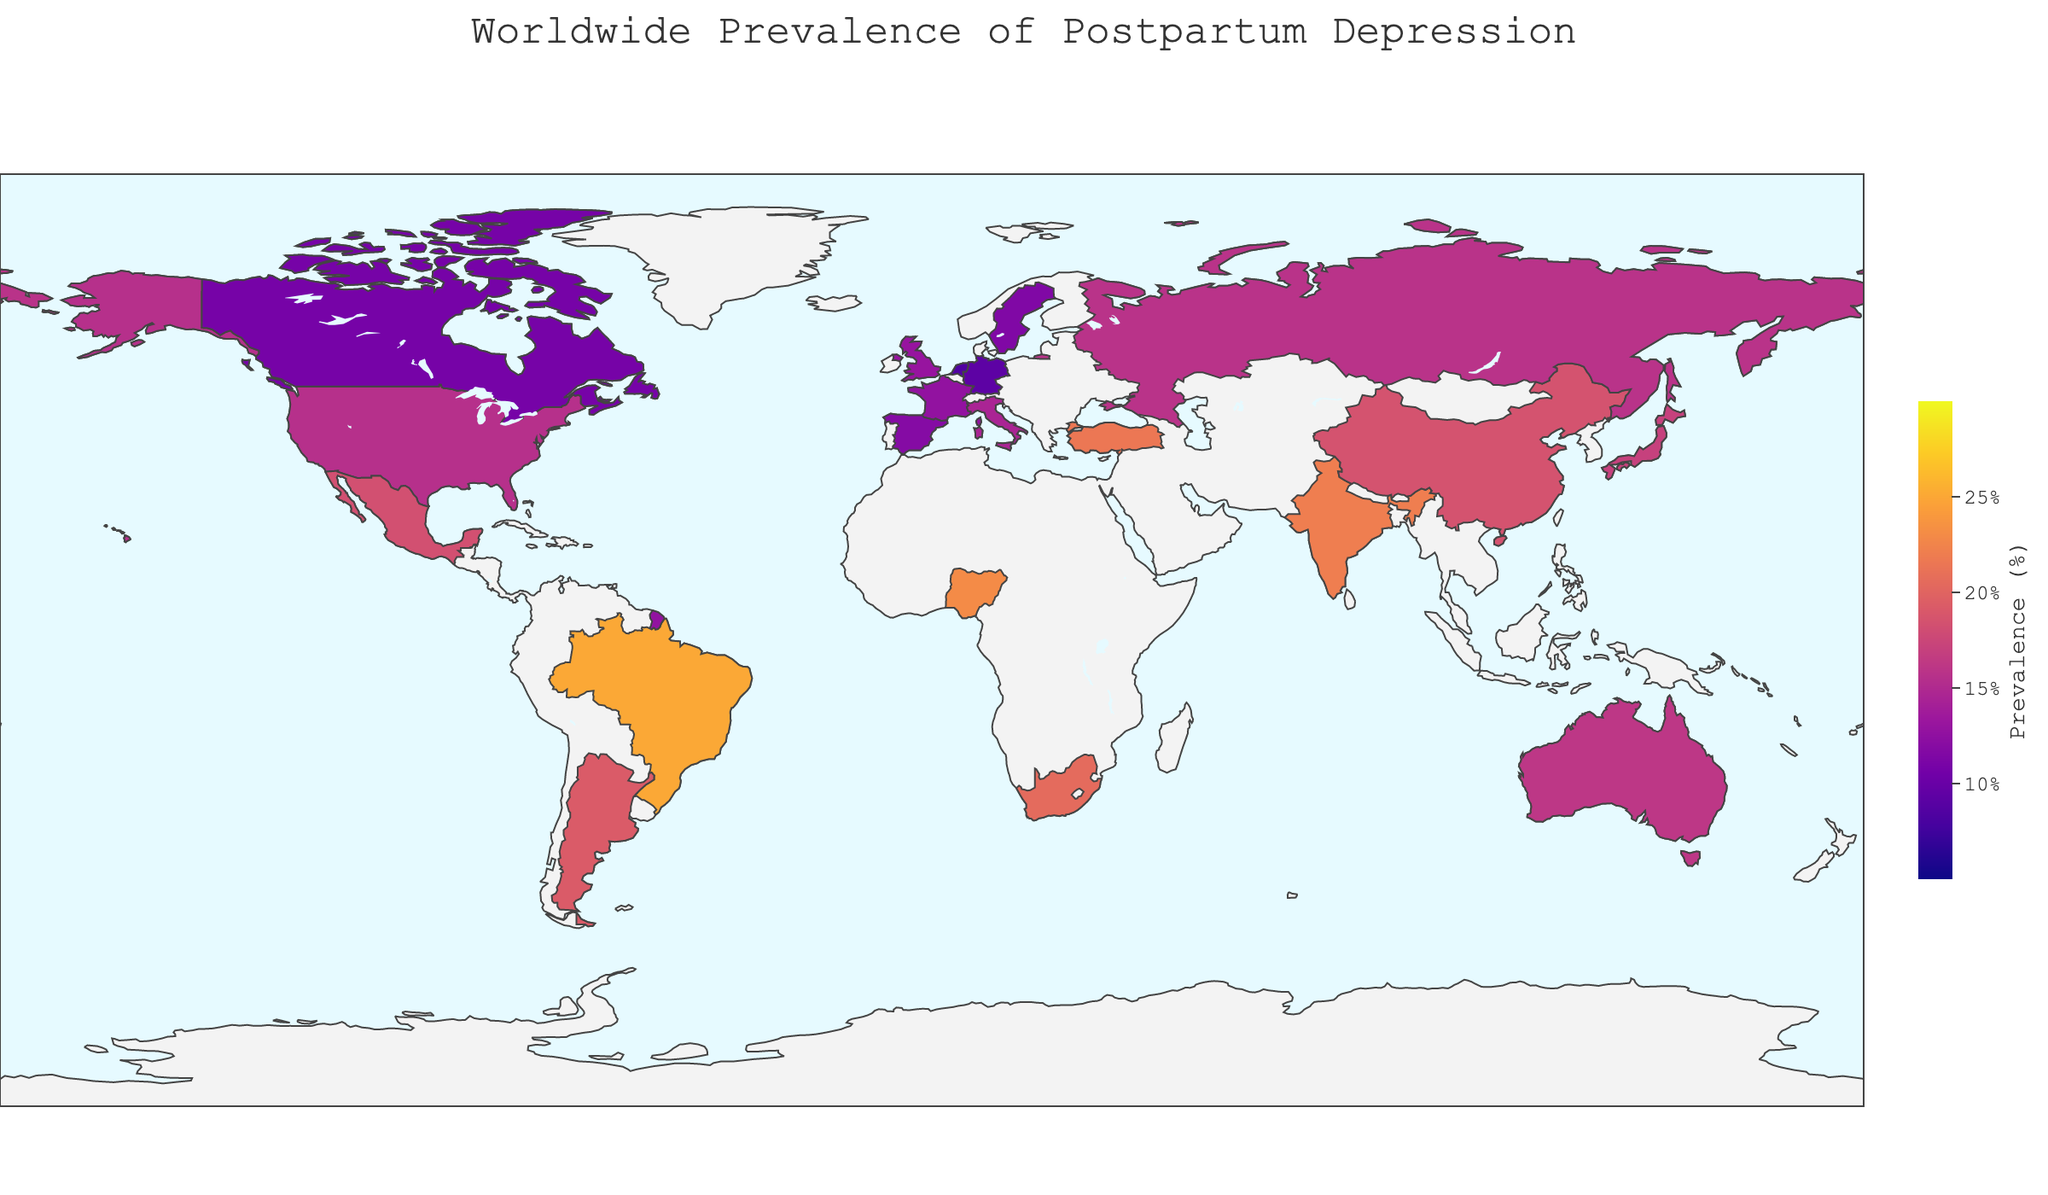What is the title of the map? The title is usually displayed at the top of the map to describe what it represents. In this case, the title is visible as "Worldwide Prevalence of Postpartum Depression".
Answer: Worldwide Prevalence of Postpartum Depression Which country has the highest prevalence of postpartum depression? By looking at the map, the countries are colored based on the prevalence rate. The darkest color on the map denotes the highest prevalence rate, identifying Brazil as having the highest rate of 25.0%.
Answer: Brazil What is the prevalence of postpartum depression in China? To find the prevalence for a specific country, locate China on the map and observe the color coding or hover to see the specific rate.
Answer: 18.5% Which country has a lower prevalence of postpartum depression, Germany or the Netherlands? Compare the shades of color on Germany and the Netherlands. Germany is colored lighter compared to the Netherlands, indicating it has a lower prevalence. Specifically, Germany has a prevalence of 9.2%, while the Netherlands has 8.5%.
Answer: Netherlands Calculate the average prevalence of postpartum depression for the countries listed. Sum all prevalence rates: (15.5 + 13.0 + 10.8 + 16.1 + 17.0 + 22.0 + 25.0 + 11.5 + 23.0 + 20.5 + 18.3 + 9.2 + 12.7 + 14.5 + 18.5 + 11.8 + 19.2 + 8.5 + 15.8 + 21.5) = 313.9 and divide by the number of countries (20).
Answer: 15.695 Which continent shows a generally higher prevalence of postpartum depression? Analyze the coloring trends on different continents. Countries in South America and Africa display darker shades compared to those in Europe and North America, indicating generally higher prevalence rates.
Answer: South America and Africa Describe the color scale used for the prevalence rates. The color scale ranges from a lighter color for lower prevalence rates to a darker color for higher prevalence rates. The scale is continuous and uses shades of colors from light to dark following the "Plasma" color scheme.
Answer: Light to dark scale (Plasma) Which three countries in the figure have the lowest prevalence rates of postpartum depression? Identify the three countries with the lightest coloration on the map and verify their rates: Netherlands (8.5%), Germany (9.2%), and Canada (10.8%).
Answer: Netherlands, Germany, Canada Is there any country with a prevalence rate exactly on the color scale ticks of 10%, 15%, 20%, or 25%? Check if any country's prevalence is exactly at one of the predefined ticks on the color bar. Brazil at 25.0% fulfills this condition.
Answer: Brazil at 25% What is the difference in prevalence between Australia and India? Locate the prevalence rates for Australia (16.1%) and India (22.0%), then subtract the lower from the higher value: 22.0% - 16.1% = 5.9%.
Answer: 5.9% 